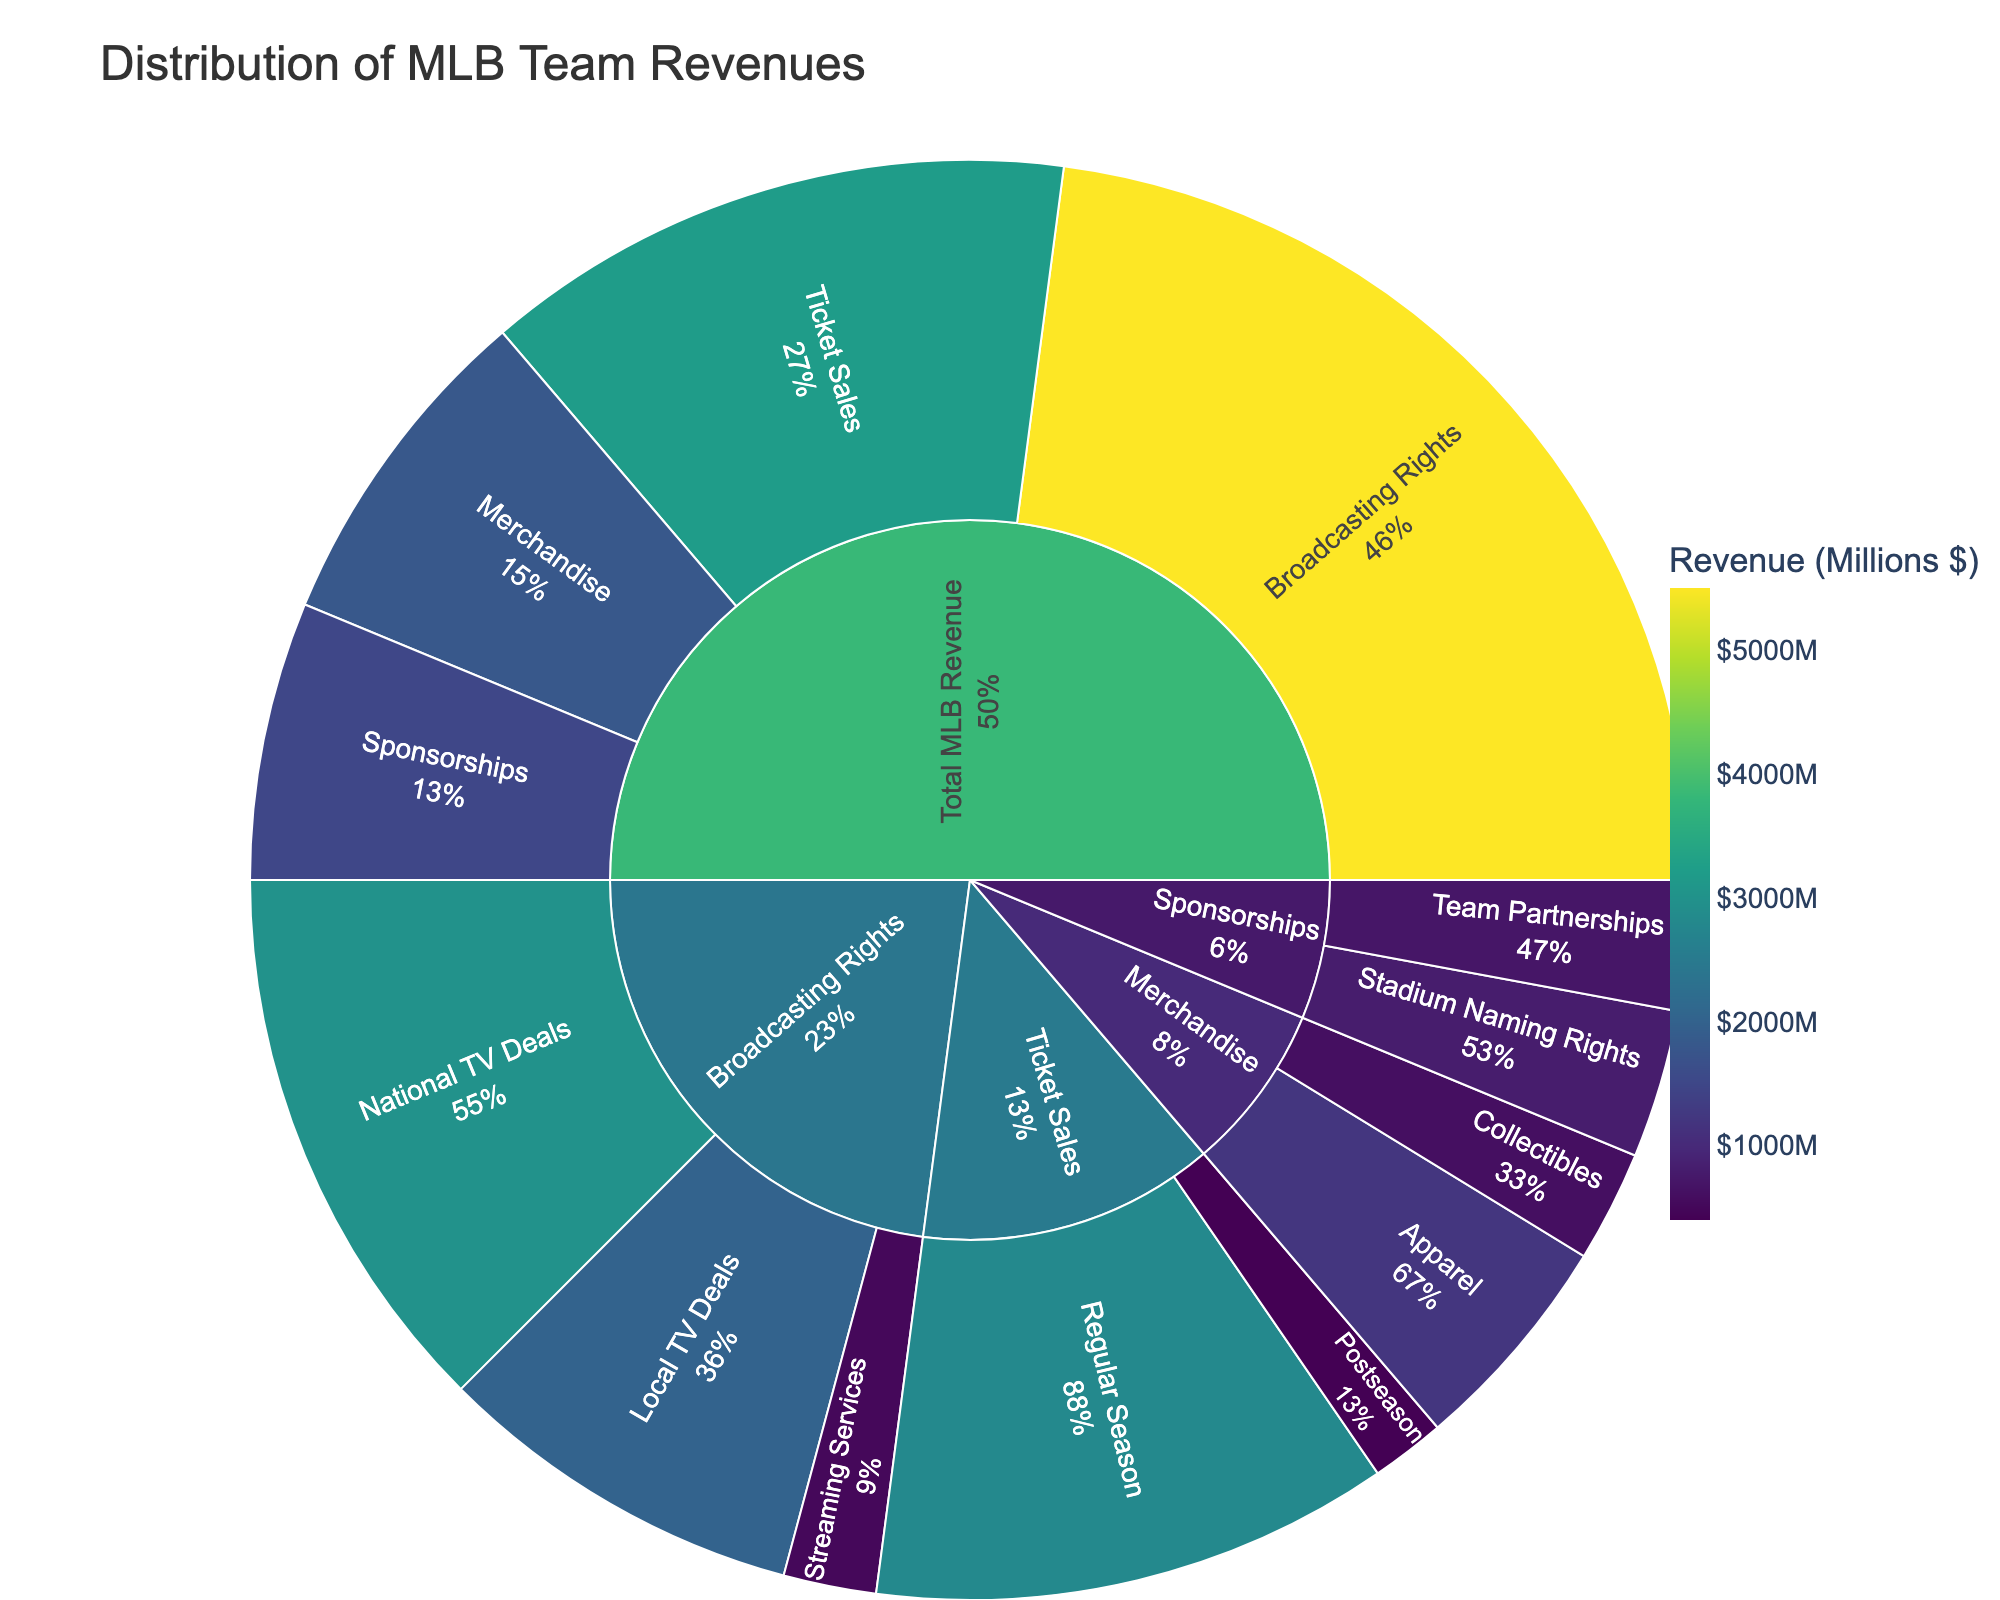What's the title of the plot? The title is usually located at the top of the figure. In this plot, it reads 'Distribution of MLB Team Revenues'.
Answer: Distribution of MLB Team Revenues Which subcategory contributes the most to the total MLB revenue? By looking at the size of the segments in the sunburst plot, we can identify that 'Broadcasting Rights' has the largest segment.
Answer: Broadcasting Rights What is the total value of revenues from Ticket Sales and Merchandise combined? The sum of revenues from Ticket Sales (3200) and Merchandise (1800) equals 5000.
Answer: 5000 Which source between 'National TV Deals' and 'Local TV Deals' under Broadcasting Rights generates more revenue? We compare the segments for 'National TV Deals' and 'Local TV Deals'. 'National TV Deals' has a value of 3000, which is greater than 2000 for 'Local TV Deals'.
Answer: National TV Deals What percentage of the Ticket Sales revenue comes from Regular Season sales? Ticket Sales total to 3200. Regular Season sales are 2800. The percentage is calculated as (2800 / 3200) * 100 = 87.5%.
Answer: 87.5% How do revenues from Streaming Services under Broadcasting Rights compare to Postseason Ticket Sales? Streaming Services revenue under Broadcasting Rights is 500, whereas Postseason Ticket Sales are 400. 500 is greater than 400.
Answer: Streaming Services > Postseason Ticket Sales What are the two subcategories under Sponsorships, and how much revenue do they generate respectively? We can see two segments under Sponsorships: 'Stadium Naming Rights' (800) and 'Team Partnerships' (700).
Answer: Stadium Naming Rights (800) and Team Partnerships (700) Calculate the difference in revenue between Apparel and Collectibles under Merchandise. Apparel generates 1200, while Collectibles generate 600. The difference is 1200 - 600 = 600.
Answer: 600 What portion of the total revenue comes from Sponsorships? The total revenue is the sum of all the categories. Sponsorships generate 1500 out of (3200 + 1800 + 5500 + 1500 = 12000). The portion is (1500 / 12000) * 100 = 12.5%.
Answer: 12.5% Does the revenue from Regular Season Ticket Sales exceed the combined revenue from all Sponsorships? Regular Season Ticket Sales revenue is 2800. All Sponsorships combined are 1500. 2800 is greater than 1500.
Answer: Yes 